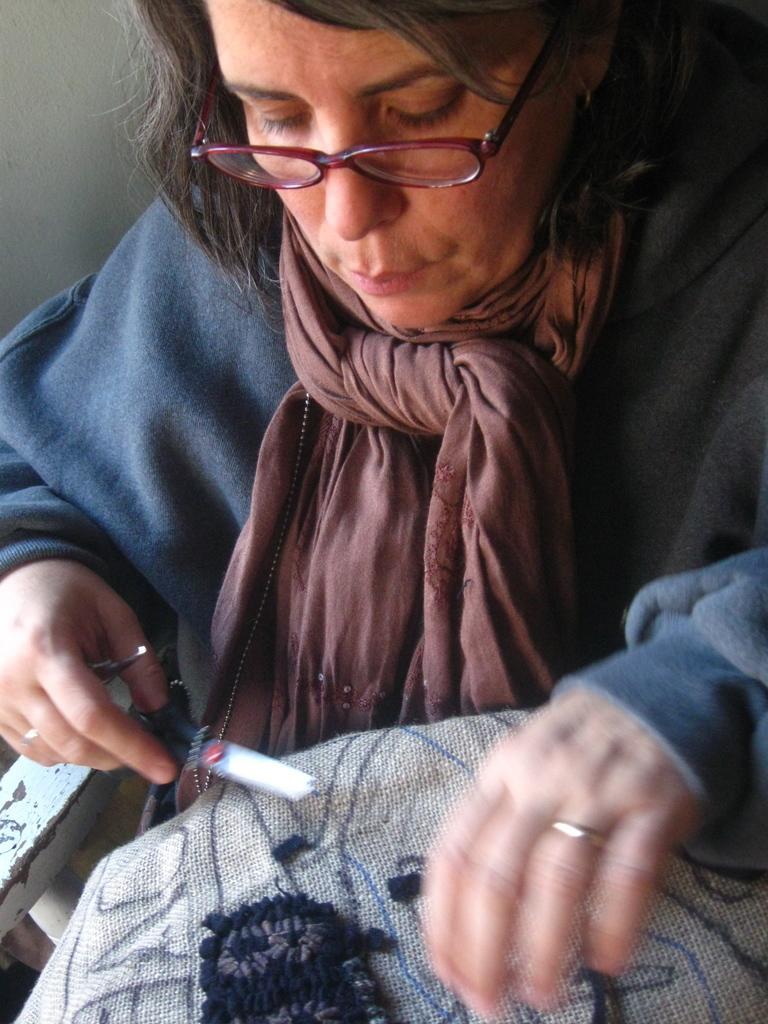How would you summarize this image in a sentence or two? In the picture, there is a woman sitting on a chair. She is holding some object in her hand and there is a jute cloth on the woman's lap,she is wearing a stole around her neck and she is also wearing spectacles. 